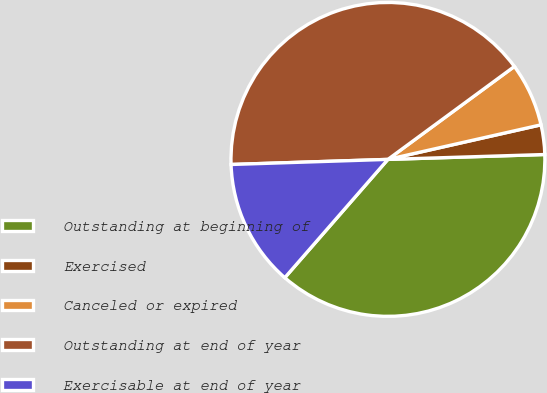<chart> <loc_0><loc_0><loc_500><loc_500><pie_chart><fcel>Outstanding at beginning of<fcel>Exercised<fcel>Canceled or expired<fcel>Outstanding at end of year<fcel>Exercisable at end of year<nl><fcel>36.91%<fcel>3.04%<fcel>6.55%<fcel>40.43%<fcel>13.07%<nl></chart> 